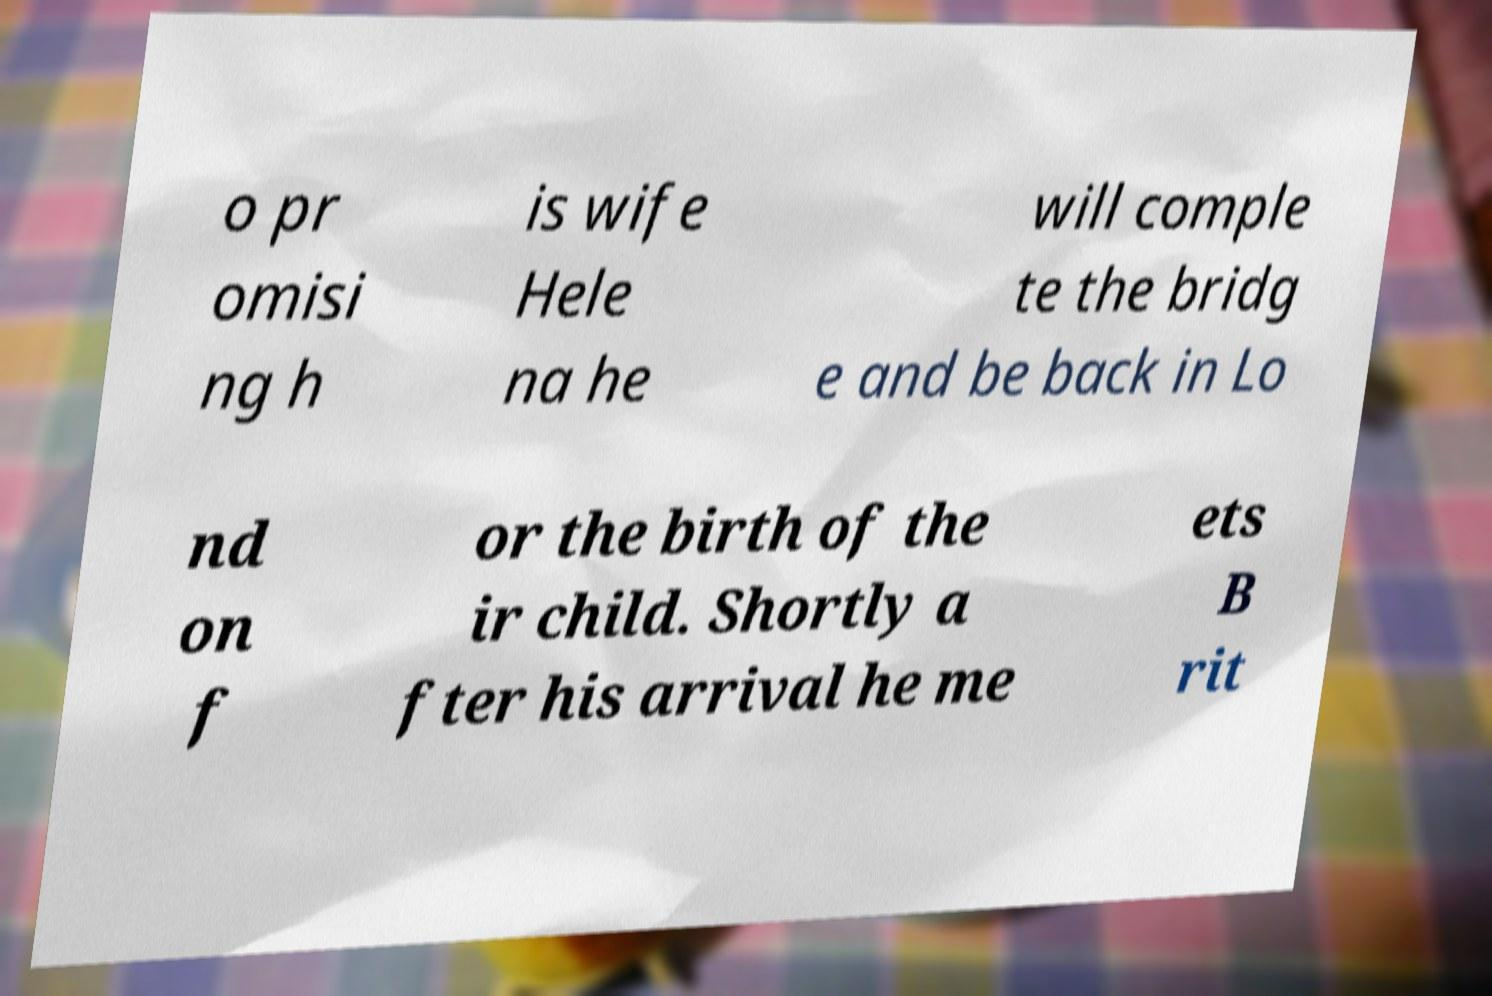What messages or text are displayed in this image? I need them in a readable, typed format. o pr omisi ng h is wife Hele na he will comple te the bridg e and be back in Lo nd on f or the birth of the ir child. Shortly a fter his arrival he me ets B rit 